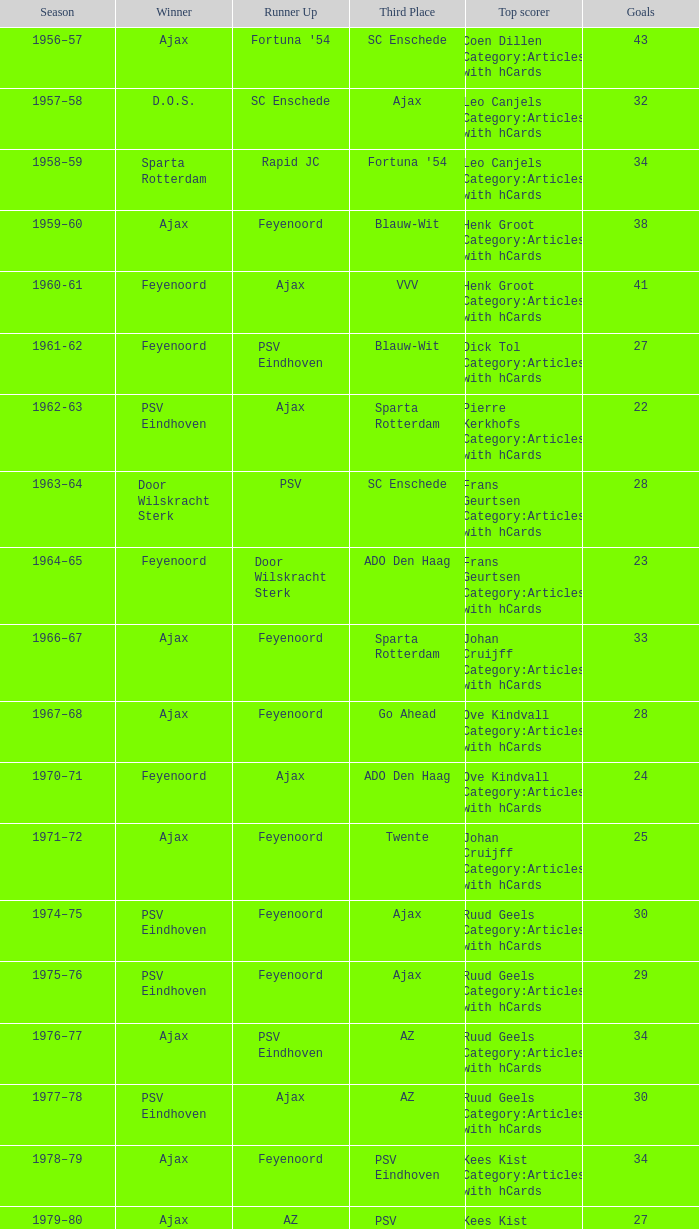When az is the runner up nad feyenoord came in third place how many overall winners are there? 1.0. 